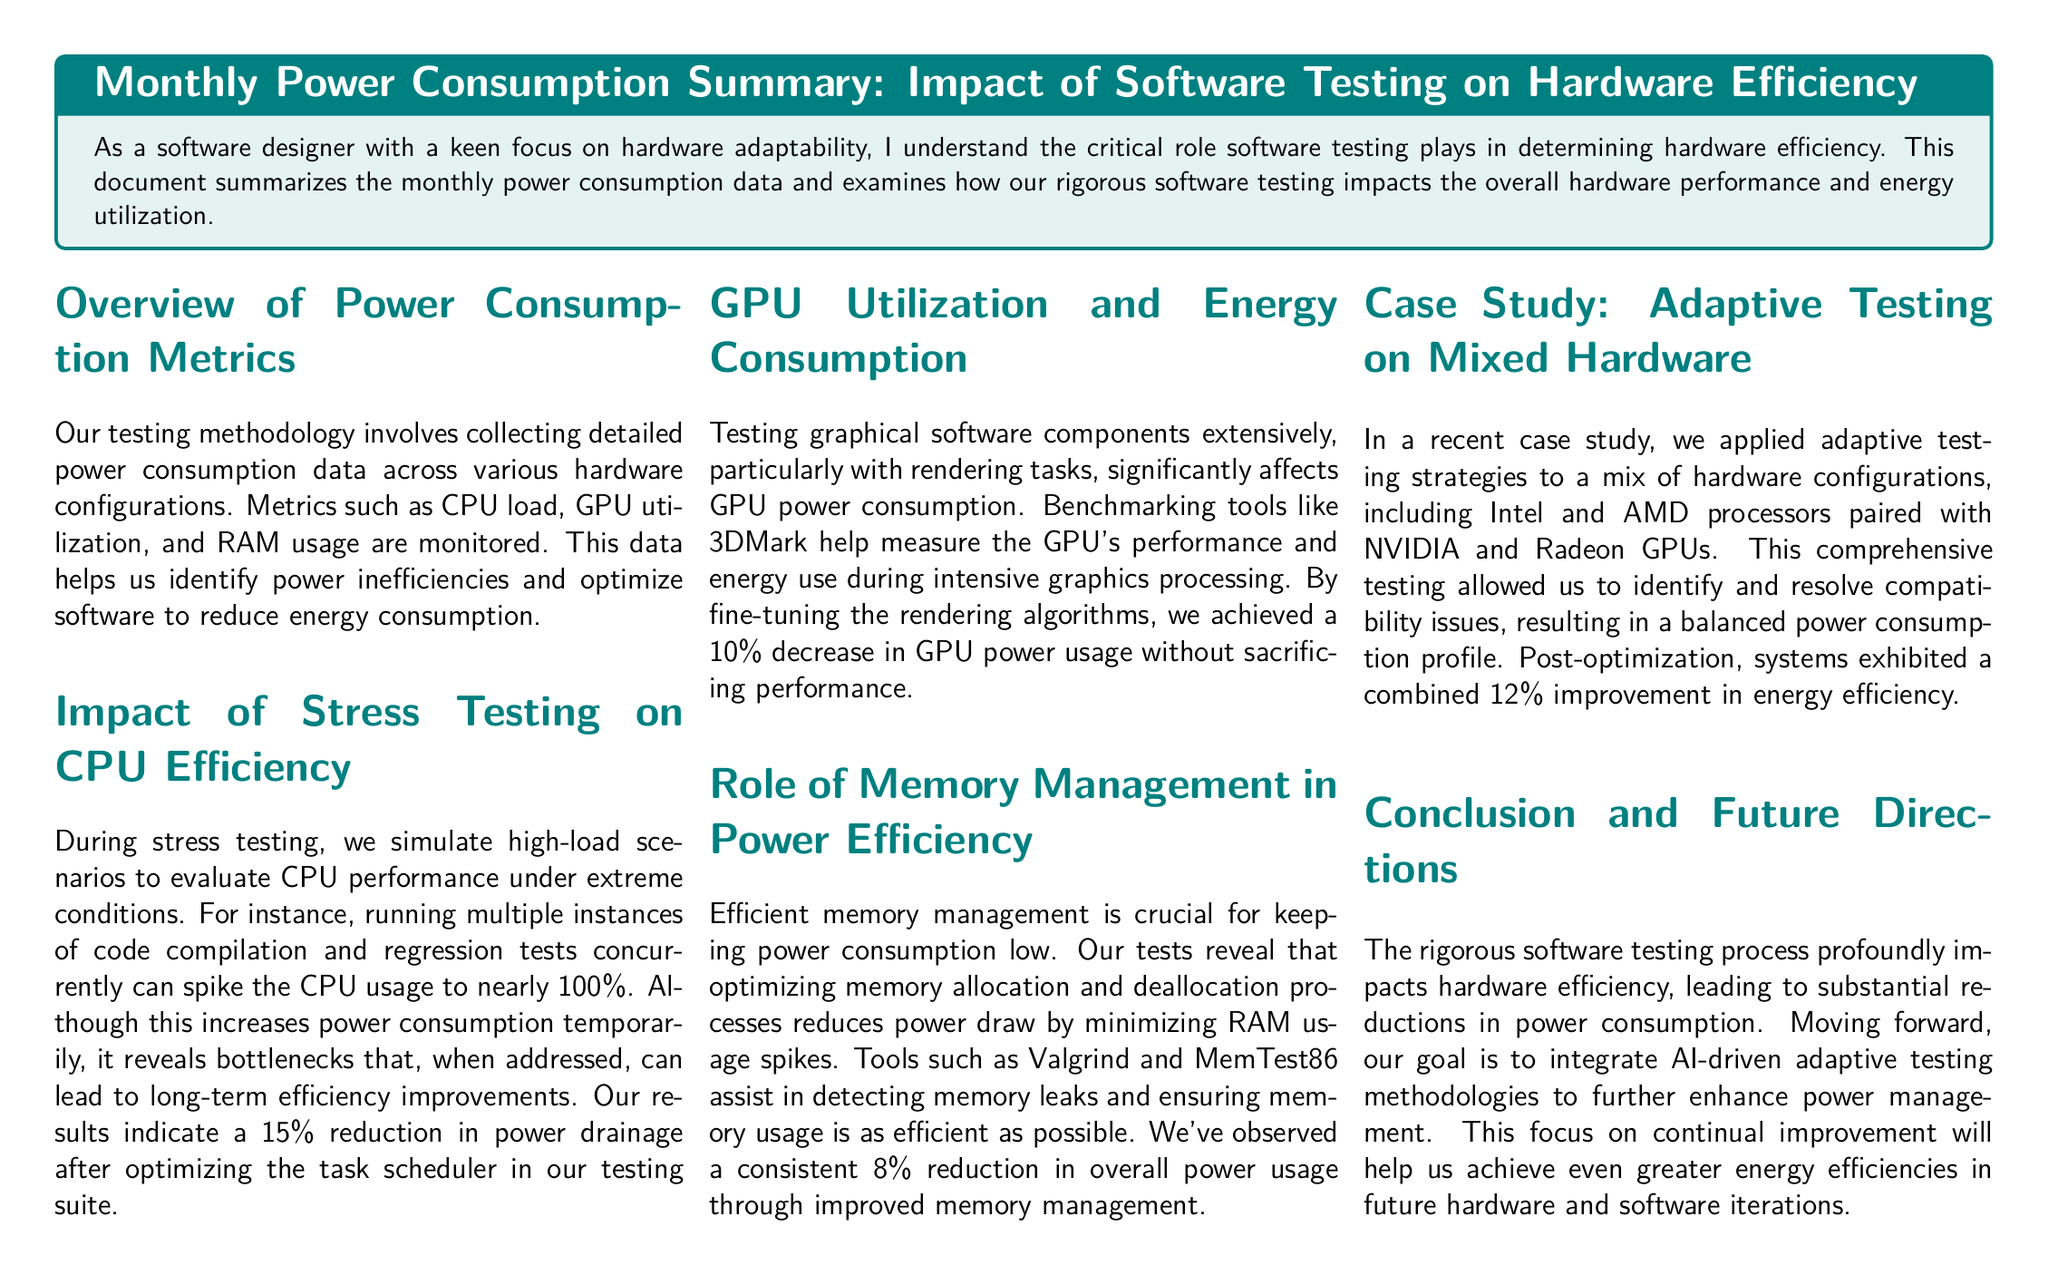What is the percentage reduction in power drainage after optimizing the task scheduler? The document states that there is a 15% reduction in power drainage after optimizing the task scheduler.
Answer: 15% What tools are mentioned for detecting memory leaks? The document lists Valgrind and MemTest86 as tools for detecting memory leaks.
Answer: Valgrind and MemTest86 What is the overall power usage reduction achieved through improved memory management? The document reports a consistent 8% reduction in overall power usage through improved memory management.
Answer: 8% What was the combined improvement in energy efficiency from adaptive testing on mixed hardware? According to the document, there was a combined 12% improvement in energy efficiency from adaptive testing on mixed hardware.
Answer: 12% Which benchmarking tool is used for GPU performance measurement? The document mentions 3DMark as the benchmarking tool for GPU performance measurement.
Answer: 3DMark What impact does stress testing have on CPU power consumption? During stress testing, CPU usage spikes to nearly 100%, temporarily increasing power consumption but leading to long-term efficiency improvements.
Answer: Increase What is the focus of future hardware and software iterations? The document states that the future focus is on integrating AI-driven adaptive testing methodologies to enhance power management.
Answer: AI-driven adaptive testing What section discusses the impact of graphical software testing? The section titled "GPU Utilization and Energy Consumption" discusses the impact of graphical software testing.
Answer: GPU Utilization and Energy Consumption What is the role of efficient memory management according to the document? The document emphasizes that efficient memory management is crucial for keeping power consumption low.
Answer: Crucial for keeping power consumption low 